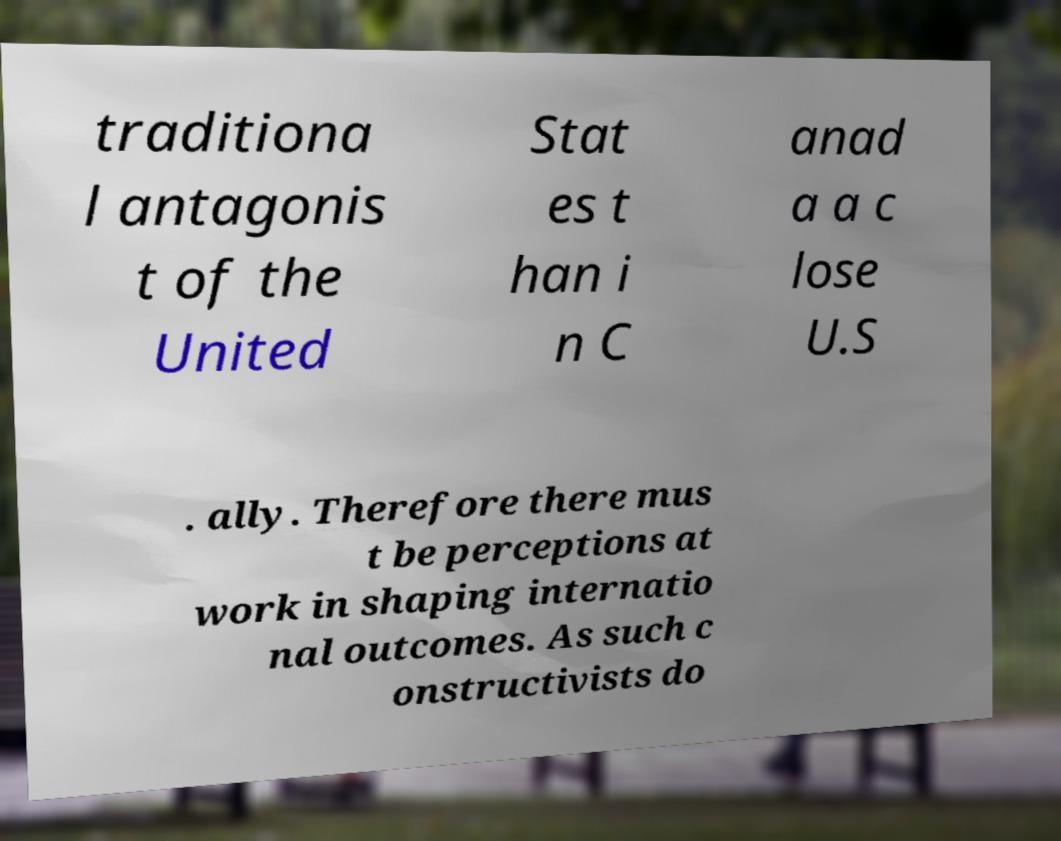Could you assist in decoding the text presented in this image and type it out clearly? traditiona l antagonis t of the United Stat es t han i n C anad a a c lose U.S . ally. Therefore there mus t be perceptions at work in shaping internatio nal outcomes. As such c onstructivists do 